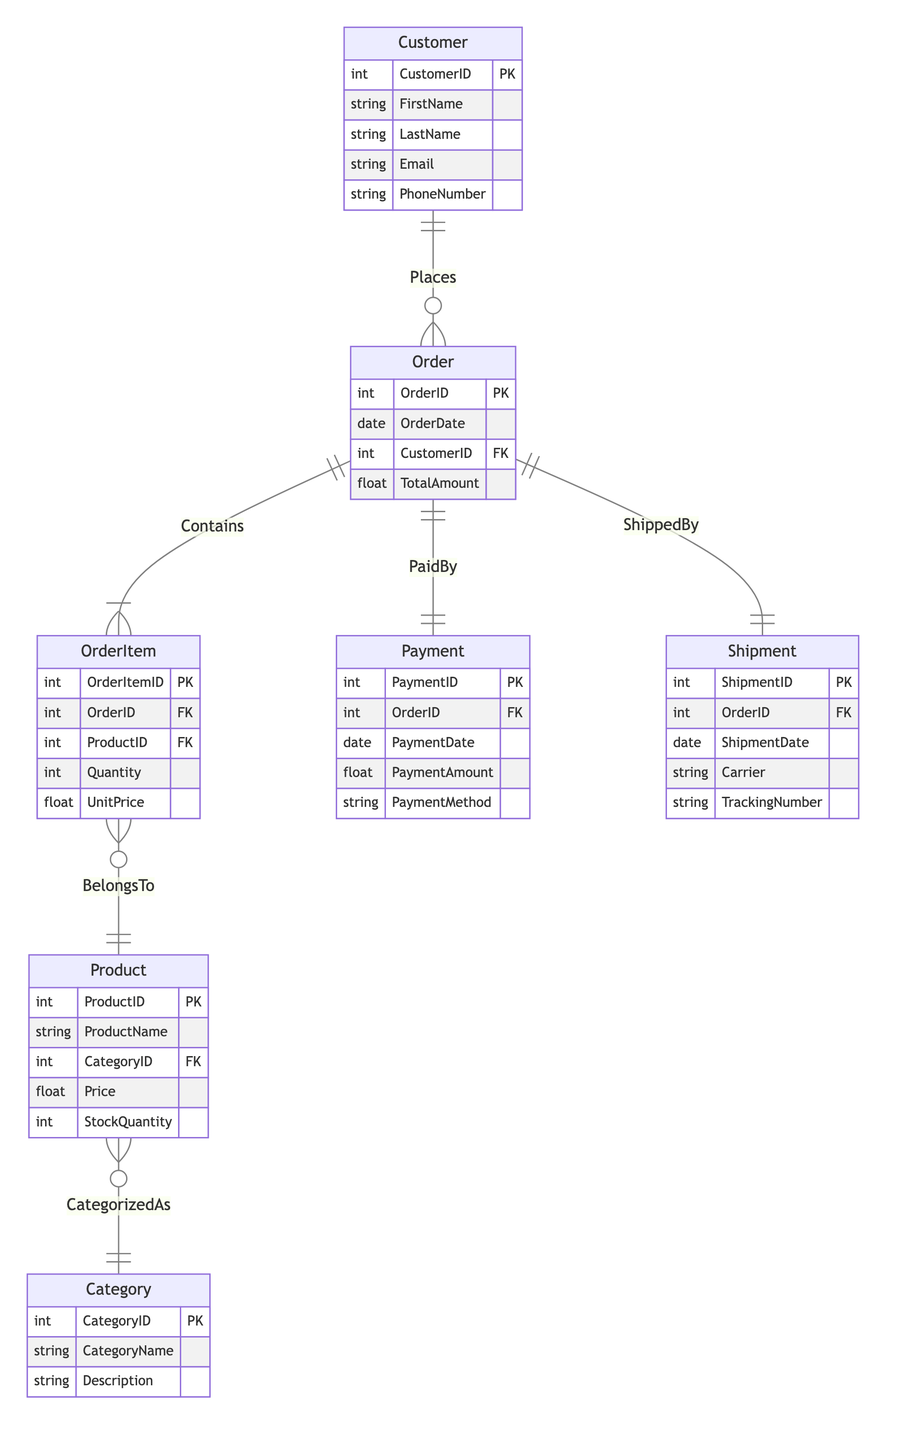What's the primary key of the Customer entity? The primary key for the Customer entity is identified under its attributes section. It is denoted as CustomerID, which uniquely identifies each customer in the e-commerce system.
Answer: CustomerID How many entities are present in the diagram? By counting the number of unique entities listed in the diagram, we find that there are six entities: Customer, Order, OrderItem, Product, Category, Payment, and Shipment. Therefore, the total count is six.
Answer: 6 What relationship exists between Order and Payment? The relationship between Order and Payment is labeled as "PaidBy". This indicates that each order is associated with exactly one payment. In the cardinality notation, this is represented as "1:1".
Answer: PaidBy Which entity has a foreign key reference to Category? Upon examining the relationships and attributes, the Product entity contains a foreign key reference to Category through the attribute CategoryID. This establishes a link between Product and Category.
Answer: Product How many attributes does the OrderItem entity have? The attributes of OrderItem can be counted from the data provided in the diagram. It has five attributes: OrderItemID, OrderID, ProductID, Quantity, and UnitPrice. Thus, the total number of attributes is five.
Answer: 5 What is the cardinality of the relationship between Product and Category? The relationship between Product and Category is defined as "CategorizedAs". This implies that many products can belong to a single category, denoting a cardinality of "M:1" where M represents multiple products linked to one category.
Answer: M:1 Which entity is responsible for capturing the PaymentDate? The attribute PaymentDate is found within the Payment entity. This denotes the date on which the payment was made for an order.
Answer: Payment Is there a direct relationship between Customer and Product? Analyzing the diagram and the relationships listed, there is no direct relationship connecting Customer and Product. The relationships are established through the Order entity, which acts as a linkage between them.
Answer: No 